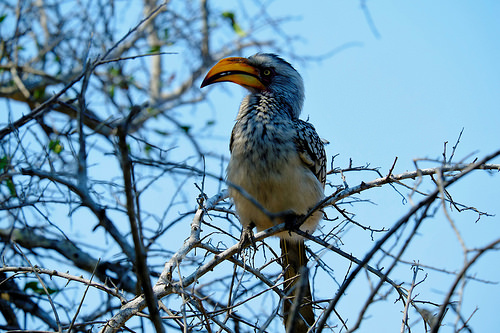<image>
Is there a bird on the branch? Yes. Looking at the image, I can see the bird is positioned on top of the branch, with the branch providing support. Is the beak to the left of the branch? No. The beak is not to the left of the branch. From this viewpoint, they have a different horizontal relationship. 